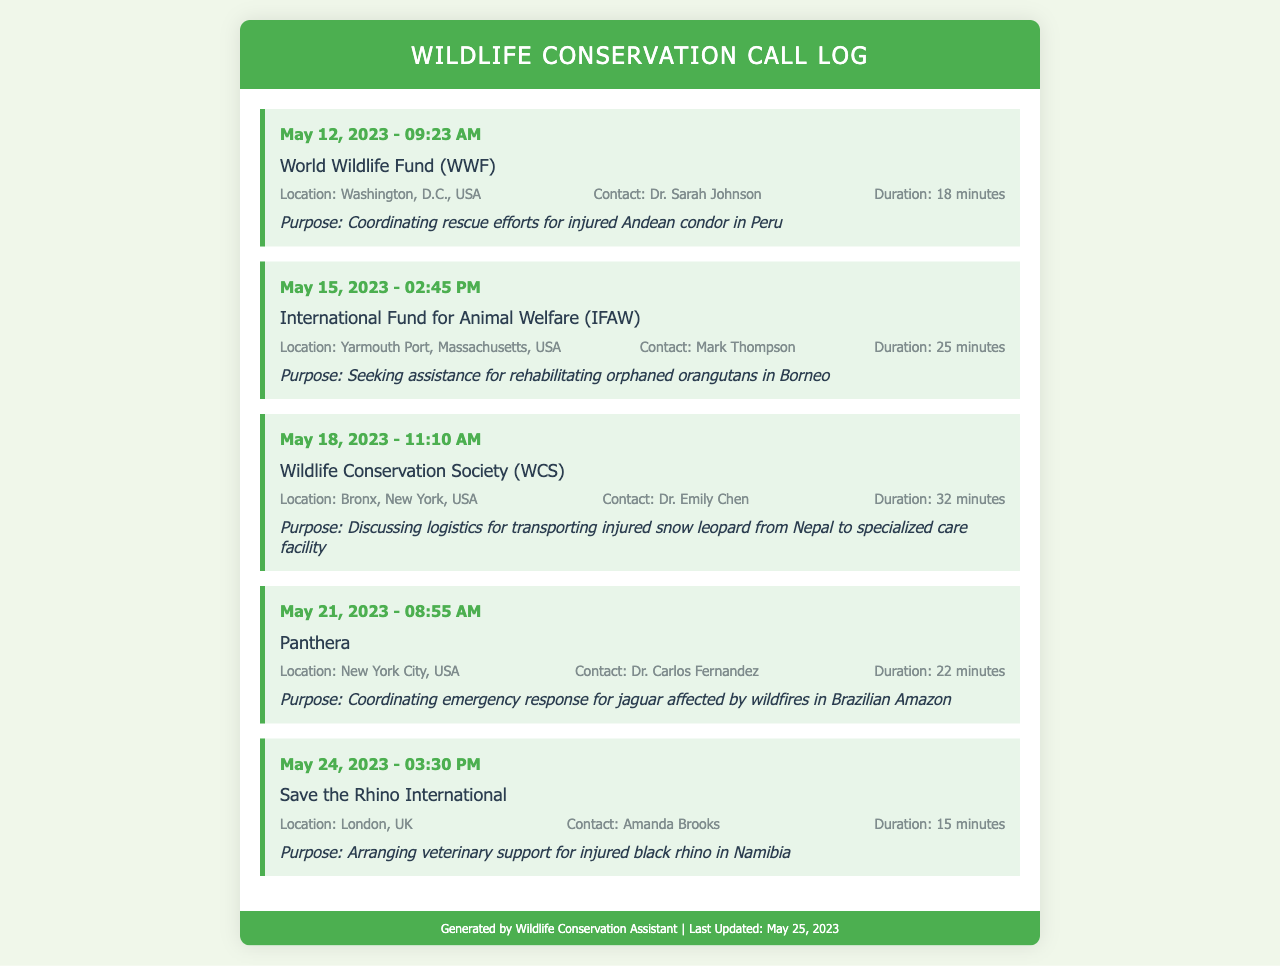What organization was contacted on May 12, 2023? The document lists the call to the World Wildlife Fund (WWF) on this date.
Answer: World Wildlife Fund (WWF) Who was the contact person during the call with IFAW? The entry for IFAW mentions Mark Thompson as the contact.
Answer: Mark Thompson What was the duration of the call with the Wildlife Conservation Society? The call entry specifies that the duration was 32 minutes.
Answer: 32 minutes What is the purpose of the call made to Save the Rhino International? The purpose stated in the document is arranging veterinary support for injured black rhino in Namibia.
Answer: Arranging veterinary support for injured black rhino in Namibia How many calls were made in May 2023? The document lists five different calls made in that month.
Answer: 5 What animal was discussed in relation to the call with Panthera? The call entry highlights a jaguar affected by wildfires in the Brazilian Amazon.
Answer: Jaguar Which organization is located in London? The document notes that Save the Rhino International is located in London, UK.
Answer: Save the Rhino International What was the purpose of the call on May 21, 2023? The entry indicates the purpose was coordinating emergency response for jaguar affected by wildfires in Brazilian Amazon.
Answer: Coordinating emergency response for jaguar affected by wildfires in Brazilian Amazon What was the contact person's name for the World Wildlife Fund? The document specifies Dr. Sarah Johnson as the contact person for WWF.
Answer: Dr. Sarah Johnson 